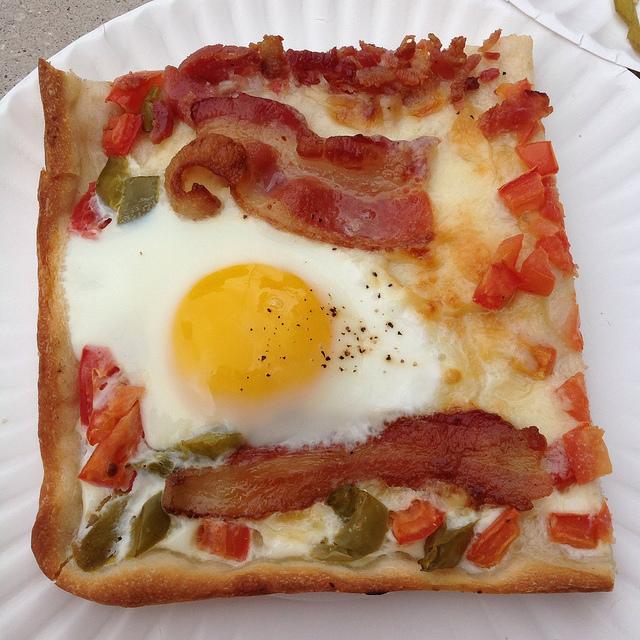Is the food wrapped in foil?
Answer briefly. No. What is the material of the plate that the pizza is placed on?
Concise answer only. Paper. Is this a normal pizza?
Give a very brief answer. No. Is the egg scrambled?
Concise answer only. No. 